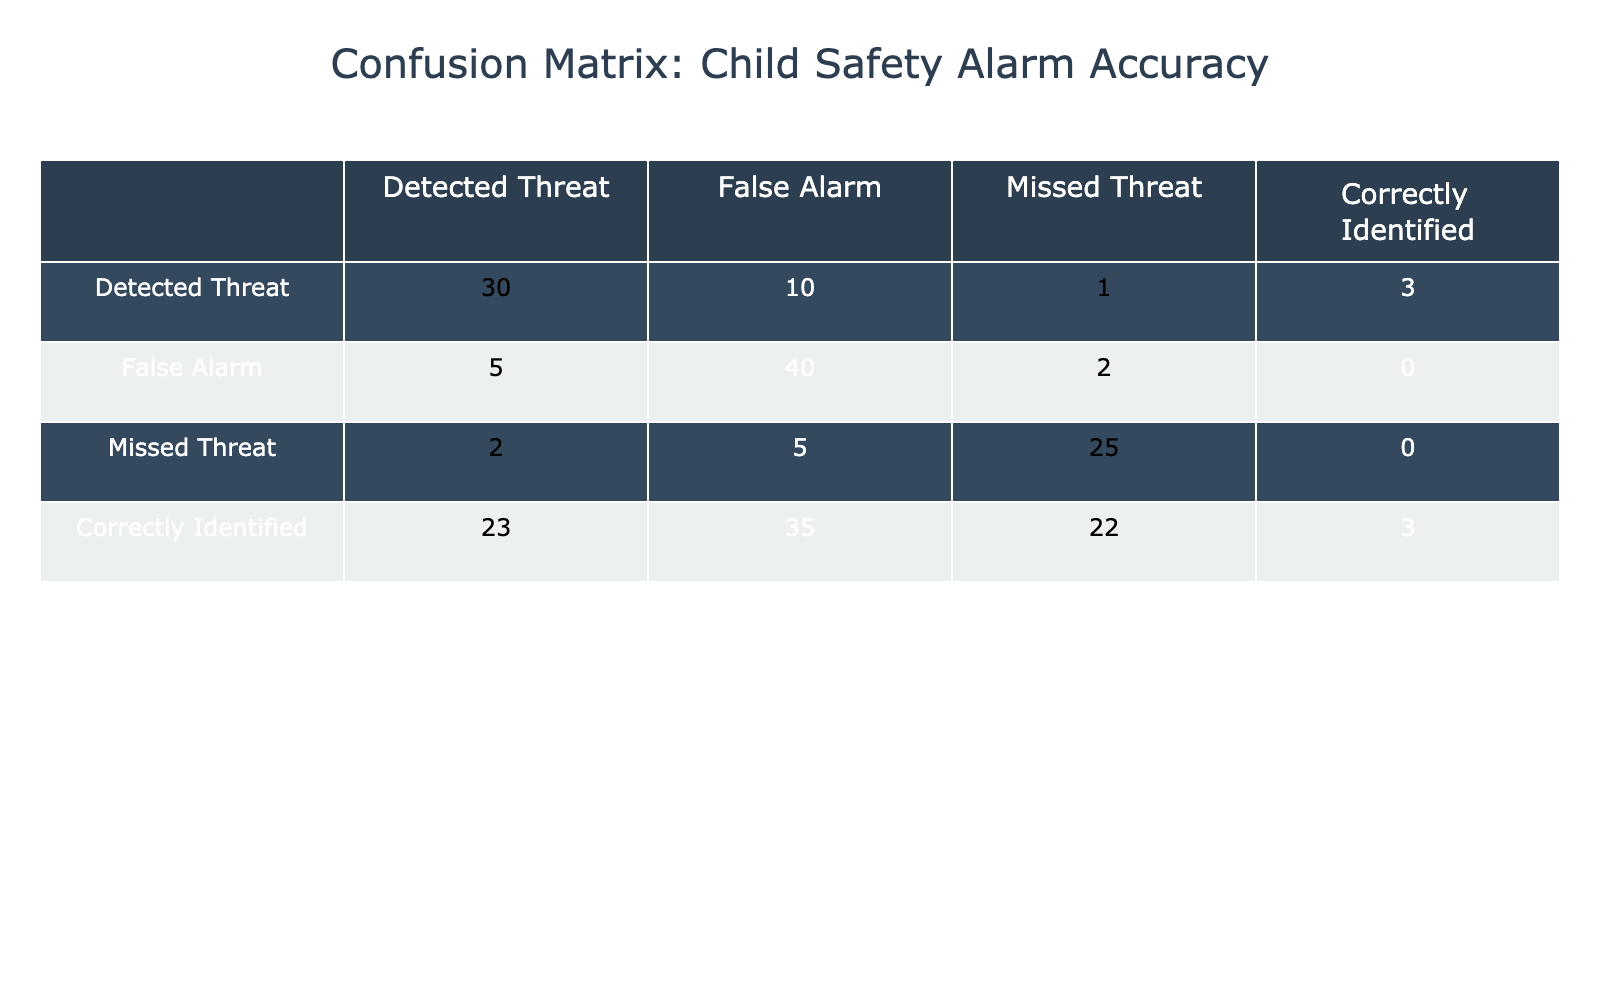What is the total number of detected threats? To find the total detected threats, sum the values in the 'Detected Threat' row: 30 (correctly identified) + 5 (false alarm) + 2 (missed threat) = 37.
Answer: 37 What is the number of false alarms? The number of false alarms is found in the 'False Alarm' row, where there are 10 (detected threats) + 40 (correctly identified) + 5 (missed threats) = 55.
Answer: 55 Are there more correctly identified threats or false alarms? The number of correctly identified threats is 23, and the number of false alarms is 40. Since 23 < 40, there are more false alarms than correctly identified threats.
Answer: Yes What is the total number of missed threats? The total number of missed threats can be found by summing the values in the 'Missed Threat' row: 1 (detected threat) + 2 (false alarm) + 25 (correctly identified) = 28.
Answer: 28 What percentage of actual threats were correctly identified? For the correctly identified threats, we have 23 out of a total of 30 detected threats. The percentage is calculated as (23 / 30) * 100 = 76.67%.
Answer: 76.67% Which category had the highest number of false alarms? The 'False Alarm' row shows the highest number of false alarms with 40 correctly identified and 5 missed threats, totaling 45 false alarms. This indicates that it is followed by categories that report as false alarms less than this.
Answer: False Alarm How many total incidents (detection, false alarm, missed threat, correctly identified) were reported? To calculate total incidents, sum all values in the confusion matrix. From the table: 30 + 5 + 2 + 23 + 10 + 40 + 5 + 35 + 1 + 2 + 25 + 22 + 3 + 0 + 0 + 3 = 189.
Answer: 189 What is the difference between detected threats and missed threats? The detected threats total 30 (from the 'Detected Threat' row), and the missed threats total 2. Thus, the difference is 30 - 2 = 28.
Answer: 28 